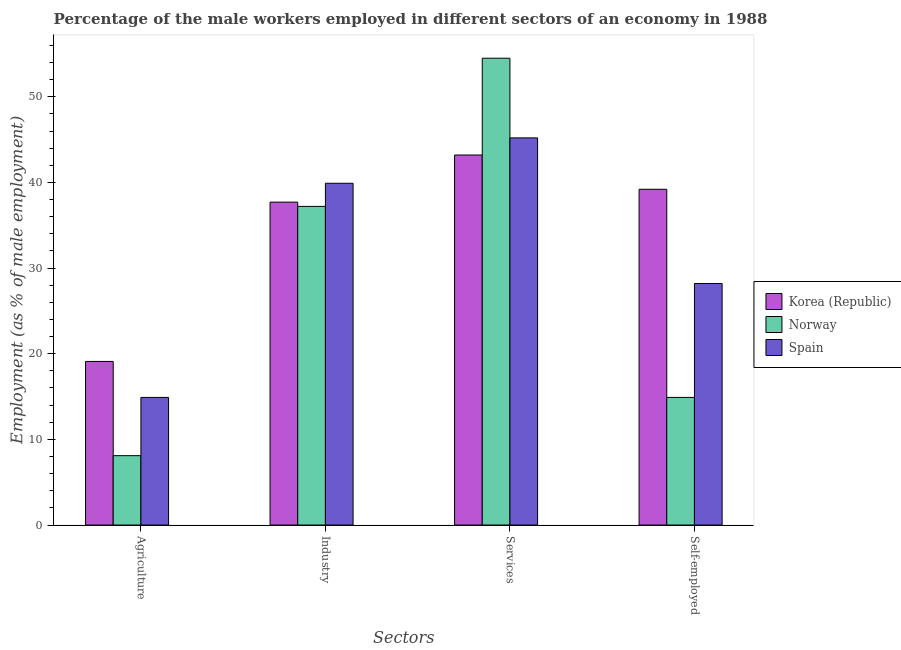How many different coloured bars are there?
Your response must be concise. 3. How many groups of bars are there?
Offer a terse response. 4. Are the number of bars on each tick of the X-axis equal?
Keep it short and to the point. Yes. How many bars are there on the 4th tick from the right?
Provide a short and direct response. 3. What is the label of the 2nd group of bars from the left?
Give a very brief answer. Industry. What is the percentage of male workers in services in Korea (Republic)?
Your answer should be very brief. 43.2. Across all countries, what is the maximum percentage of male workers in agriculture?
Ensure brevity in your answer.  19.1. Across all countries, what is the minimum percentage of male workers in services?
Your answer should be compact. 43.2. What is the total percentage of male workers in services in the graph?
Offer a terse response. 142.9. What is the difference between the percentage of male workers in agriculture in Norway and that in Spain?
Ensure brevity in your answer.  -6.8. What is the difference between the percentage of male workers in services in Norway and the percentage of male workers in industry in Spain?
Your answer should be compact. 14.6. What is the average percentage of self employed male workers per country?
Provide a succinct answer. 27.43. What is the difference between the percentage of self employed male workers and percentage of male workers in services in Norway?
Ensure brevity in your answer.  -39.6. In how many countries, is the percentage of male workers in industry greater than 36 %?
Ensure brevity in your answer.  3. What is the ratio of the percentage of self employed male workers in Spain to that in Norway?
Offer a terse response. 1.89. Is the percentage of male workers in services in Norway less than that in Korea (Republic)?
Offer a very short reply. No. What is the difference between the highest and the second highest percentage of male workers in services?
Ensure brevity in your answer.  9.3. What is the difference between the highest and the lowest percentage of self employed male workers?
Make the answer very short. 24.3. Is the sum of the percentage of male workers in industry in Korea (Republic) and Spain greater than the maximum percentage of male workers in agriculture across all countries?
Ensure brevity in your answer.  Yes. Is it the case that in every country, the sum of the percentage of male workers in agriculture and percentage of male workers in services is greater than the sum of percentage of self employed male workers and percentage of male workers in industry?
Offer a terse response. Yes. What does the 3rd bar from the left in Industry represents?
Provide a succinct answer. Spain. What does the 1st bar from the right in Industry represents?
Provide a short and direct response. Spain. Are all the bars in the graph horizontal?
Keep it short and to the point. No. How many countries are there in the graph?
Your answer should be very brief. 3. Are the values on the major ticks of Y-axis written in scientific E-notation?
Your answer should be compact. No. Does the graph contain grids?
Offer a very short reply. No. Where does the legend appear in the graph?
Keep it short and to the point. Center right. What is the title of the graph?
Provide a short and direct response. Percentage of the male workers employed in different sectors of an economy in 1988. Does "Pakistan" appear as one of the legend labels in the graph?
Make the answer very short. No. What is the label or title of the X-axis?
Provide a short and direct response. Sectors. What is the label or title of the Y-axis?
Your answer should be compact. Employment (as % of male employment). What is the Employment (as % of male employment) of Korea (Republic) in Agriculture?
Ensure brevity in your answer.  19.1. What is the Employment (as % of male employment) of Norway in Agriculture?
Provide a succinct answer. 8.1. What is the Employment (as % of male employment) of Spain in Agriculture?
Provide a short and direct response. 14.9. What is the Employment (as % of male employment) in Korea (Republic) in Industry?
Provide a short and direct response. 37.7. What is the Employment (as % of male employment) in Norway in Industry?
Provide a short and direct response. 37.2. What is the Employment (as % of male employment) in Spain in Industry?
Make the answer very short. 39.9. What is the Employment (as % of male employment) in Korea (Republic) in Services?
Your answer should be very brief. 43.2. What is the Employment (as % of male employment) of Norway in Services?
Provide a succinct answer. 54.5. What is the Employment (as % of male employment) in Spain in Services?
Provide a short and direct response. 45.2. What is the Employment (as % of male employment) in Korea (Republic) in Self-employed?
Your answer should be compact. 39.2. What is the Employment (as % of male employment) of Norway in Self-employed?
Your answer should be very brief. 14.9. What is the Employment (as % of male employment) in Spain in Self-employed?
Make the answer very short. 28.2. Across all Sectors, what is the maximum Employment (as % of male employment) of Korea (Republic)?
Provide a succinct answer. 43.2. Across all Sectors, what is the maximum Employment (as % of male employment) of Norway?
Offer a terse response. 54.5. Across all Sectors, what is the maximum Employment (as % of male employment) in Spain?
Offer a terse response. 45.2. Across all Sectors, what is the minimum Employment (as % of male employment) in Korea (Republic)?
Your answer should be compact. 19.1. Across all Sectors, what is the minimum Employment (as % of male employment) of Norway?
Give a very brief answer. 8.1. Across all Sectors, what is the minimum Employment (as % of male employment) in Spain?
Provide a short and direct response. 14.9. What is the total Employment (as % of male employment) of Korea (Republic) in the graph?
Your answer should be very brief. 139.2. What is the total Employment (as % of male employment) of Norway in the graph?
Make the answer very short. 114.7. What is the total Employment (as % of male employment) in Spain in the graph?
Offer a very short reply. 128.2. What is the difference between the Employment (as % of male employment) of Korea (Republic) in Agriculture and that in Industry?
Your answer should be compact. -18.6. What is the difference between the Employment (as % of male employment) of Norway in Agriculture and that in Industry?
Keep it short and to the point. -29.1. What is the difference between the Employment (as % of male employment) in Korea (Republic) in Agriculture and that in Services?
Ensure brevity in your answer.  -24.1. What is the difference between the Employment (as % of male employment) of Norway in Agriculture and that in Services?
Ensure brevity in your answer.  -46.4. What is the difference between the Employment (as % of male employment) in Spain in Agriculture and that in Services?
Offer a very short reply. -30.3. What is the difference between the Employment (as % of male employment) of Korea (Republic) in Agriculture and that in Self-employed?
Provide a succinct answer. -20.1. What is the difference between the Employment (as % of male employment) of Spain in Agriculture and that in Self-employed?
Keep it short and to the point. -13.3. What is the difference between the Employment (as % of male employment) in Korea (Republic) in Industry and that in Services?
Your answer should be very brief. -5.5. What is the difference between the Employment (as % of male employment) of Norway in Industry and that in Services?
Keep it short and to the point. -17.3. What is the difference between the Employment (as % of male employment) in Korea (Republic) in Industry and that in Self-employed?
Your answer should be very brief. -1.5. What is the difference between the Employment (as % of male employment) in Norway in Industry and that in Self-employed?
Offer a very short reply. 22.3. What is the difference between the Employment (as % of male employment) of Spain in Industry and that in Self-employed?
Your response must be concise. 11.7. What is the difference between the Employment (as % of male employment) in Korea (Republic) in Services and that in Self-employed?
Keep it short and to the point. 4. What is the difference between the Employment (as % of male employment) of Norway in Services and that in Self-employed?
Offer a terse response. 39.6. What is the difference between the Employment (as % of male employment) in Korea (Republic) in Agriculture and the Employment (as % of male employment) in Norway in Industry?
Offer a terse response. -18.1. What is the difference between the Employment (as % of male employment) in Korea (Republic) in Agriculture and the Employment (as % of male employment) in Spain in Industry?
Make the answer very short. -20.8. What is the difference between the Employment (as % of male employment) in Norway in Agriculture and the Employment (as % of male employment) in Spain in Industry?
Make the answer very short. -31.8. What is the difference between the Employment (as % of male employment) of Korea (Republic) in Agriculture and the Employment (as % of male employment) of Norway in Services?
Your answer should be very brief. -35.4. What is the difference between the Employment (as % of male employment) of Korea (Republic) in Agriculture and the Employment (as % of male employment) of Spain in Services?
Offer a very short reply. -26.1. What is the difference between the Employment (as % of male employment) in Norway in Agriculture and the Employment (as % of male employment) in Spain in Services?
Provide a short and direct response. -37.1. What is the difference between the Employment (as % of male employment) in Norway in Agriculture and the Employment (as % of male employment) in Spain in Self-employed?
Make the answer very short. -20.1. What is the difference between the Employment (as % of male employment) of Korea (Republic) in Industry and the Employment (as % of male employment) of Norway in Services?
Your response must be concise. -16.8. What is the difference between the Employment (as % of male employment) of Korea (Republic) in Industry and the Employment (as % of male employment) of Spain in Services?
Your response must be concise. -7.5. What is the difference between the Employment (as % of male employment) in Norway in Industry and the Employment (as % of male employment) in Spain in Services?
Your response must be concise. -8. What is the difference between the Employment (as % of male employment) in Korea (Republic) in Industry and the Employment (as % of male employment) in Norway in Self-employed?
Provide a succinct answer. 22.8. What is the difference between the Employment (as % of male employment) of Korea (Republic) in Industry and the Employment (as % of male employment) of Spain in Self-employed?
Your answer should be very brief. 9.5. What is the difference between the Employment (as % of male employment) of Korea (Republic) in Services and the Employment (as % of male employment) of Norway in Self-employed?
Your answer should be compact. 28.3. What is the difference between the Employment (as % of male employment) in Korea (Republic) in Services and the Employment (as % of male employment) in Spain in Self-employed?
Give a very brief answer. 15. What is the difference between the Employment (as % of male employment) of Norway in Services and the Employment (as % of male employment) of Spain in Self-employed?
Keep it short and to the point. 26.3. What is the average Employment (as % of male employment) in Korea (Republic) per Sectors?
Offer a very short reply. 34.8. What is the average Employment (as % of male employment) of Norway per Sectors?
Provide a short and direct response. 28.68. What is the average Employment (as % of male employment) in Spain per Sectors?
Your response must be concise. 32.05. What is the difference between the Employment (as % of male employment) of Korea (Republic) and Employment (as % of male employment) of Norway in Services?
Ensure brevity in your answer.  -11.3. What is the difference between the Employment (as % of male employment) of Korea (Republic) and Employment (as % of male employment) of Norway in Self-employed?
Your response must be concise. 24.3. What is the difference between the Employment (as % of male employment) of Korea (Republic) and Employment (as % of male employment) of Spain in Self-employed?
Your answer should be compact. 11. What is the ratio of the Employment (as % of male employment) of Korea (Republic) in Agriculture to that in Industry?
Offer a terse response. 0.51. What is the ratio of the Employment (as % of male employment) of Norway in Agriculture to that in Industry?
Offer a terse response. 0.22. What is the ratio of the Employment (as % of male employment) of Spain in Agriculture to that in Industry?
Provide a short and direct response. 0.37. What is the ratio of the Employment (as % of male employment) of Korea (Republic) in Agriculture to that in Services?
Provide a short and direct response. 0.44. What is the ratio of the Employment (as % of male employment) of Norway in Agriculture to that in Services?
Your response must be concise. 0.15. What is the ratio of the Employment (as % of male employment) of Spain in Agriculture to that in Services?
Your answer should be very brief. 0.33. What is the ratio of the Employment (as % of male employment) of Korea (Republic) in Agriculture to that in Self-employed?
Offer a terse response. 0.49. What is the ratio of the Employment (as % of male employment) of Norway in Agriculture to that in Self-employed?
Make the answer very short. 0.54. What is the ratio of the Employment (as % of male employment) of Spain in Agriculture to that in Self-employed?
Make the answer very short. 0.53. What is the ratio of the Employment (as % of male employment) of Korea (Republic) in Industry to that in Services?
Offer a very short reply. 0.87. What is the ratio of the Employment (as % of male employment) in Norway in Industry to that in Services?
Provide a short and direct response. 0.68. What is the ratio of the Employment (as % of male employment) of Spain in Industry to that in Services?
Provide a succinct answer. 0.88. What is the ratio of the Employment (as % of male employment) in Korea (Republic) in Industry to that in Self-employed?
Your response must be concise. 0.96. What is the ratio of the Employment (as % of male employment) of Norway in Industry to that in Self-employed?
Ensure brevity in your answer.  2.5. What is the ratio of the Employment (as % of male employment) of Spain in Industry to that in Self-employed?
Offer a terse response. 1.41. What is the ratio of the Employment (as % of male employment) of Korea (Republic) in Services to that in Self-employed?
Your response must be concise. 1.1. What is the ratio of the Employment (as % of male employment) of Norway in Services to that in Self-employed?
Make the answer very short. 3.66. What is the ratio of the Employment (as % of male employment) in Spain in Services to that in Self-employed?
Your answer should be compact. 1.6. What is the difference between the highest and the lowest Employment (as % of male employment) in Korea (Republic)?
Make the answer very short. 24.1. What is the difference between the highest and the lowest Employment (as % of male employment) in Norway?
Your answer should be very brief. 46.4. What is the difference between the highest and the lowest Employment (as % of male employment) of Spain?
Offer a very short reply. 30.3. 